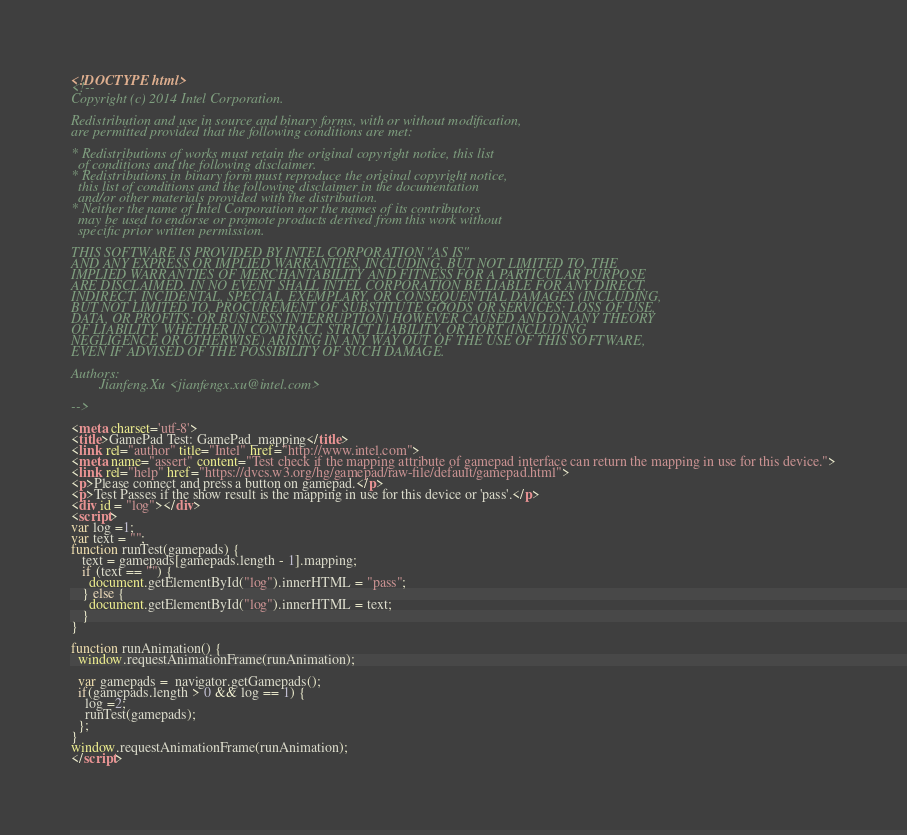<code> <loc_0><loc_0><loc_500><loc_500><_HTML_><!DOCTYPE html>
<!--
Copyright (c) 2014 Intel Corporation.

Redistribution and use in source and binary forms, with or without modification,
are permitted provided that the following conditions are met:

* Redistributions of works must retain the original copyright notice, this list
  of conditions and the following disclaimer.
* Redistributions in binary form must reproduce the original copyright notice,
  this list of conditions and the following disclaimer in the documentation
  and/or other materials provided with the distribution.
* Neither the name of Intel Corporation nor the names of its contributors
  may be used to endorse or promote products derived from this work without
  specific prior written permission.

THIS SOFTWARE IS PROVIDED BY INTEL CORPORATION "AS IS"
AND ANY EXPRESS OR IMPLIED WARRANTIES, INCLUDING, BUT NOT LIMITED TO, THE
IMPLIED WARRANTIES OF MERCHANTABILITY AND FITNESS FOR A PARTICULAR PURPOSE
ARE DISCLAIMED. IN NO EVENT SHALL INTEL CORPORATION BE LIABLE FOR ANY DIRECT,
INDIRECT, INCIDENTAL, SPECIAL, EXEMPLARY, OR CONSEQUENTIAL DAMAGES (INCLUDING,
BUT NOT LIMITED TO, PROCUREMENT OF SUBSTITUTE GOODS OR SERVICES; LOSS OF USE,
DATA, OR PROFITS; OR BUSINESS INTERRUPTION) HOWEVER CAUSED AND ON ANY THEORY
OF LIABILITY, WHETHER IN CONTRACT, STRICT LIABILITY, OR TORT (INCLUDING
NEGLIGENCE OR OTHERWISE) ARISING IN ANY WAY OUT OF THE USE OF THIS SOFTWARE,
EVEN IF ADVISED OF THE POSSIBILITY OF SUCH DAMAGE.

Authors:
        Jianfeng.Xu <jianfengx.xu@intel.com>

-->

<meta charset='utf-8'>
<title>GamePad Test: GamePad_mapping</title>
<link rel="author" title="Intel" href="http://www.intel.com">
<meta name="assert" content="Test check if the mapping attribute of gamepad interface can return the mapping in use for this device.">
<link rel="help" href="https://dvcs.w3.org/hg/gamepad/raw-file/default/gamepad.html">
<p>Please connect and press a button on gamepad.</p>
<p>Test Passes if the show result is the mapping in use for this device or 'pass'.</p>
<div id = "log"></div>
<script>
var log =1;
var text = "";
function runTest(gamepads) {
   text = gamepads[gamepads.length - 1].mapping;
   if (text == "") {
     document.getElementById("log").innerHTML = "pass";
   } else {
     document.getElementById("log").innerHTML = text;
   }
}

function runAnimation() {  
  window.requestAnimationFrame(runAnimation);
  
  var gamepads =  navigator.getGamepads();
  if(gamepads.length > 0 && log == 1) {
    log =2;
    runTest(gamepads);
  };
}
window.requestAnimationFrame(runAnimation);
</script>
</code> 